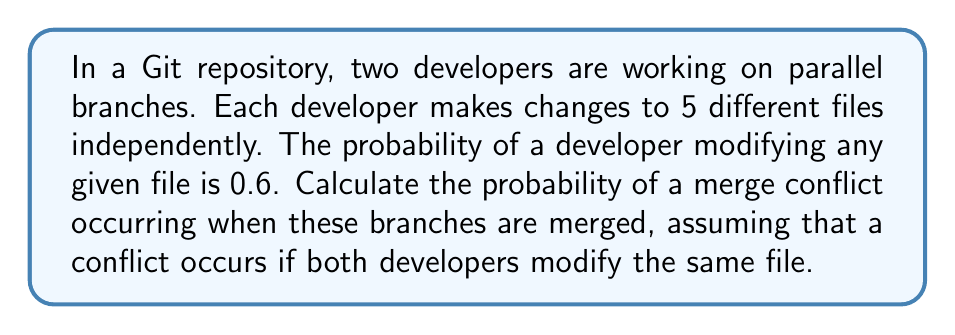What is the answer to this math problem? Let's approach this step-by-step:

1) For a merge conflict to occur, both developers must modify the same file. Let's calculate the probability for a single file:

   P(both modify) = 0.6 * 0.6 = 0.36

2) The probability of no conflict for a single file is the complement of this:

   P(no conflict for one file) = 1 - 0.36 = 0.64

3) For there to be no conflict overall, there must be no conflict in any of the 5 files. Since the modifications are independent, we can multiply the probabilities:

   P(no conflict overall) = $0.64^5$

4) The probability of at least one conflict is the complement of this:

   P(at least one conflict) = $1 - 0.64^5$

5) Let's calculate this:

   $1 - 0.64^5 = 1 - 0.10485760 = 0.89514240$

Therefore, the probability of a merge conflict occurring is approximately 0.8951 or 89.51%.
Answer: $1 - 0.64^5 \approx 0.8951$ 